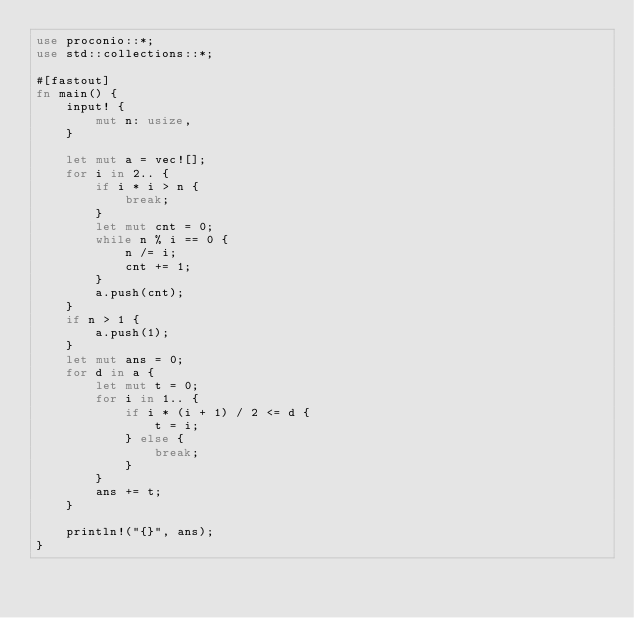Convert code to text. <code><loc_0><loc_0><loc_500><loc_500><_Rust_>use proconio::*;
use std::collections::*;

#[fastout]
fn main() {
    input! {
        mut n: usize,
    }

    let mut a = vec![];
    for i in 2.. {
        if i * i > n {
            break;
        }
        let mut cnt = 0;
        while n % i == 0 {
            n /= i;
            cnt += 1;
        }
        a.push(cnt);
    }
    if n > 1 {
        a.push(1);
    }
    let mut ans = 0;
    for d in a {
        let mut t = 0;
        for i in 1.. {
            if i * (i + 1) / 2 <= d {
                t = i;
            } else {
                break;
            }
        }
        ans += t;
    }

    println!("{}", ans);
}
</code> 